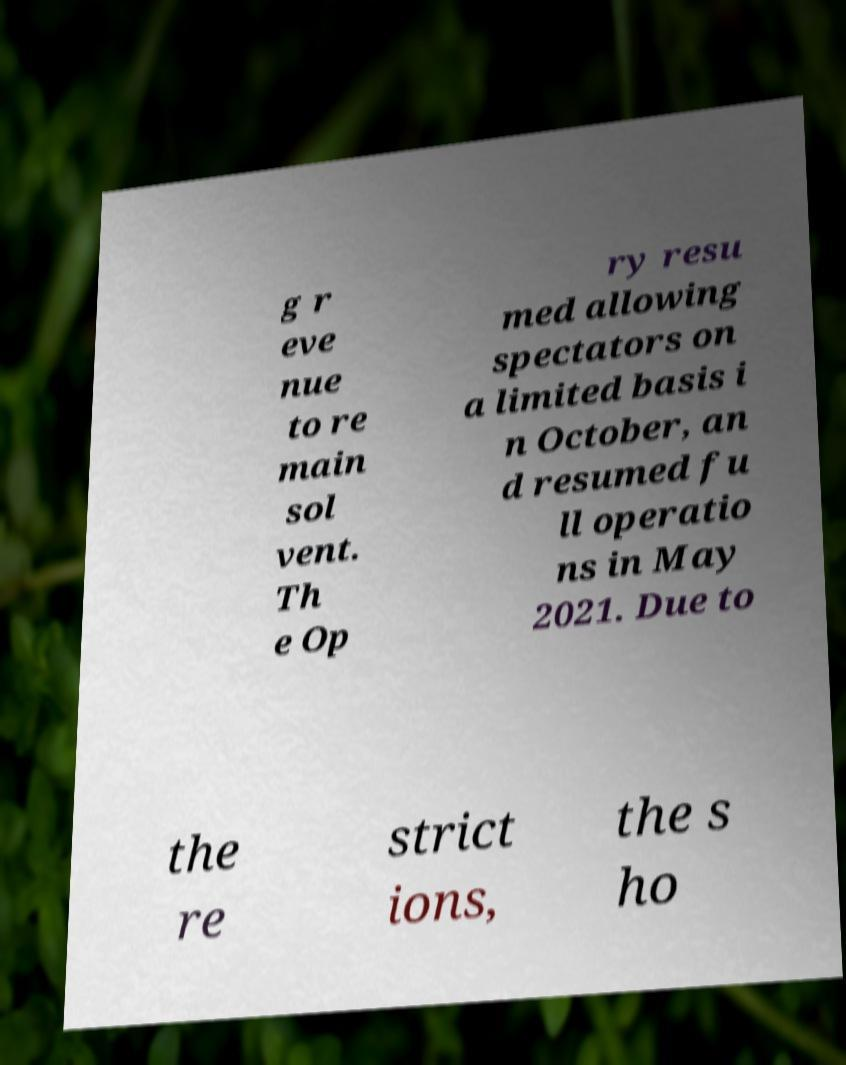Can you accurately transcribe the text from the provided image for me? g r eve nue to re main sol vent. Th e Op ry resu med allowing spectators on a limited basis i n October, an d resumed fu ll operatio ns in May 2021. Due to the re strict ions, the s ho 